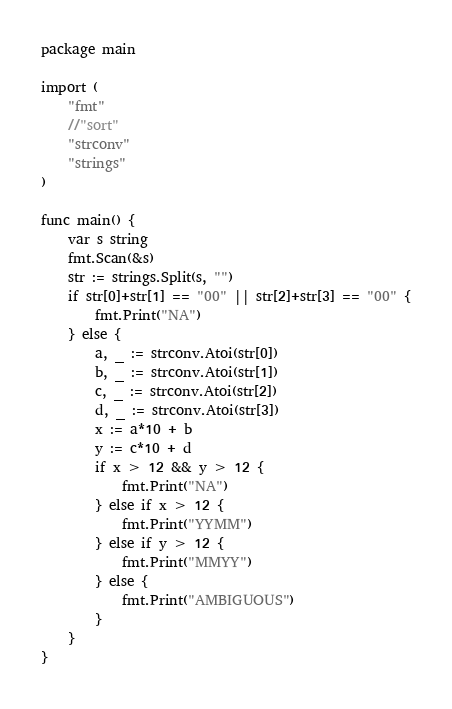<code> <loc_0><loc_0><loc_500><loc_500><_Go_>package main

import (
	"fmt"
	//"sort"
	"strconv"
	"strings"
)

func main() {
	var s string
	fmt.Scan(&s)
	str := strings.Split(s, "")
	if str[0]+str[1] == "00" || str[2]+str[3] == "00" {
		fmt.Print("NA")
	} else {
		a, _ := strconv.Atoi(str[0])
		b, _ := strconv.Atoi(str[1])
		c, _ := strconv.Atoi(str[2])
		d, _ := strconv.Atoi(str[3])
		x := a*10 + b
		y := c*10 + d
		if x > 12 && y > 12 {
			fmt.Print("NA")
		} else if x > 12 {
			fmt.Print("YYMM")
		} else if y > 12 {
			fmt.Print("MMYY")
		} else {
			fmt.Print("AMBIGUOUS")
		}
	}
}
</code> 